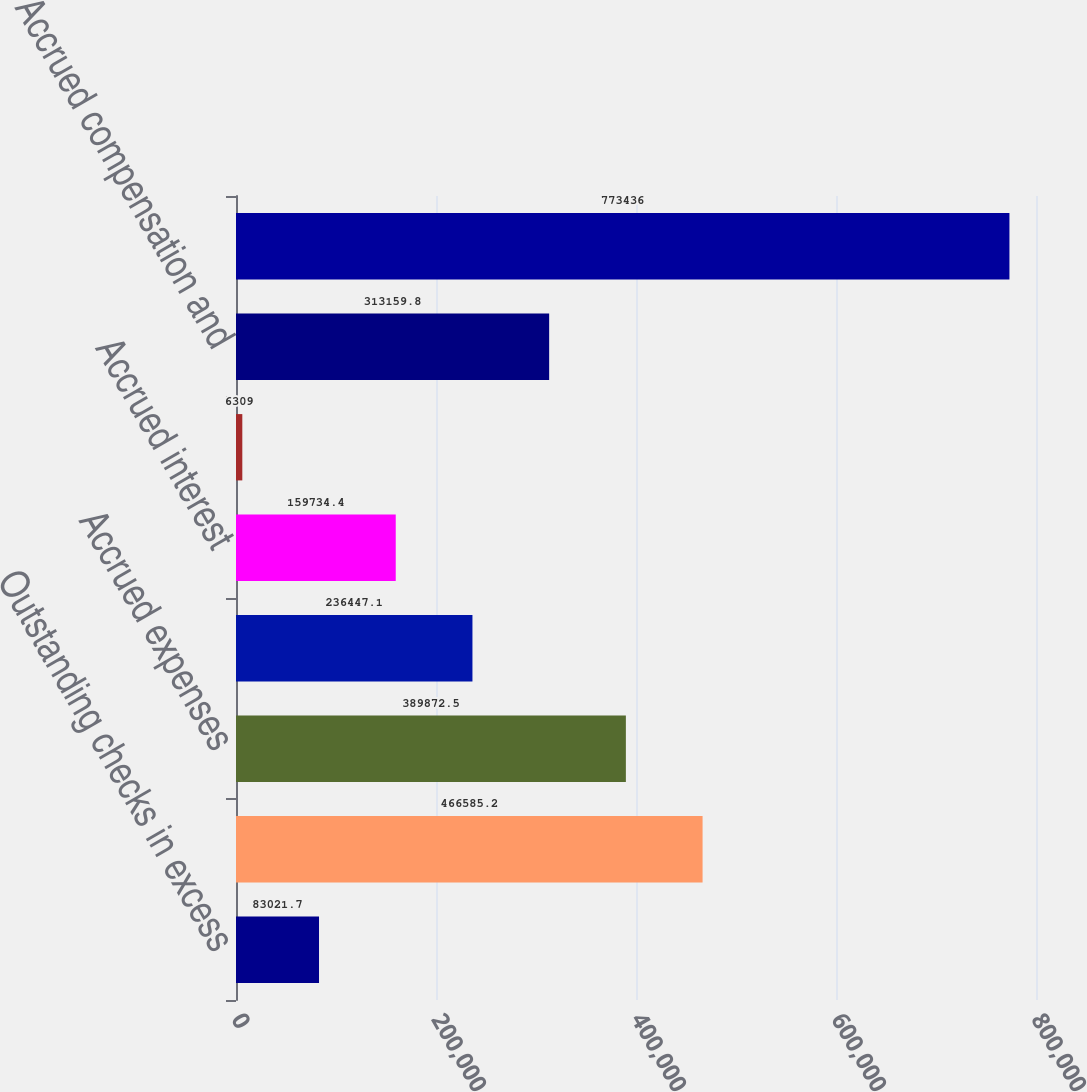Convert chart to OTSL. <chart><loc_0><loc_0><loc_500><loc_500><bar_chart><fcel>Outstanding checks in excess<fcel>Accounts payable trade<fcel>Accrued expenses<fcel>Product warranties<fcel>Accrued interest<fcel>Deferred tax liability<fcel>Accrued compensation and<fcel>Total accounts payable and<nl><fcel>83021.7<fcel>466585<fcel>389872<fcel>236447<fcel>159734<fcel>6309<fcel>313160<fcel>773436<nl></chart> 